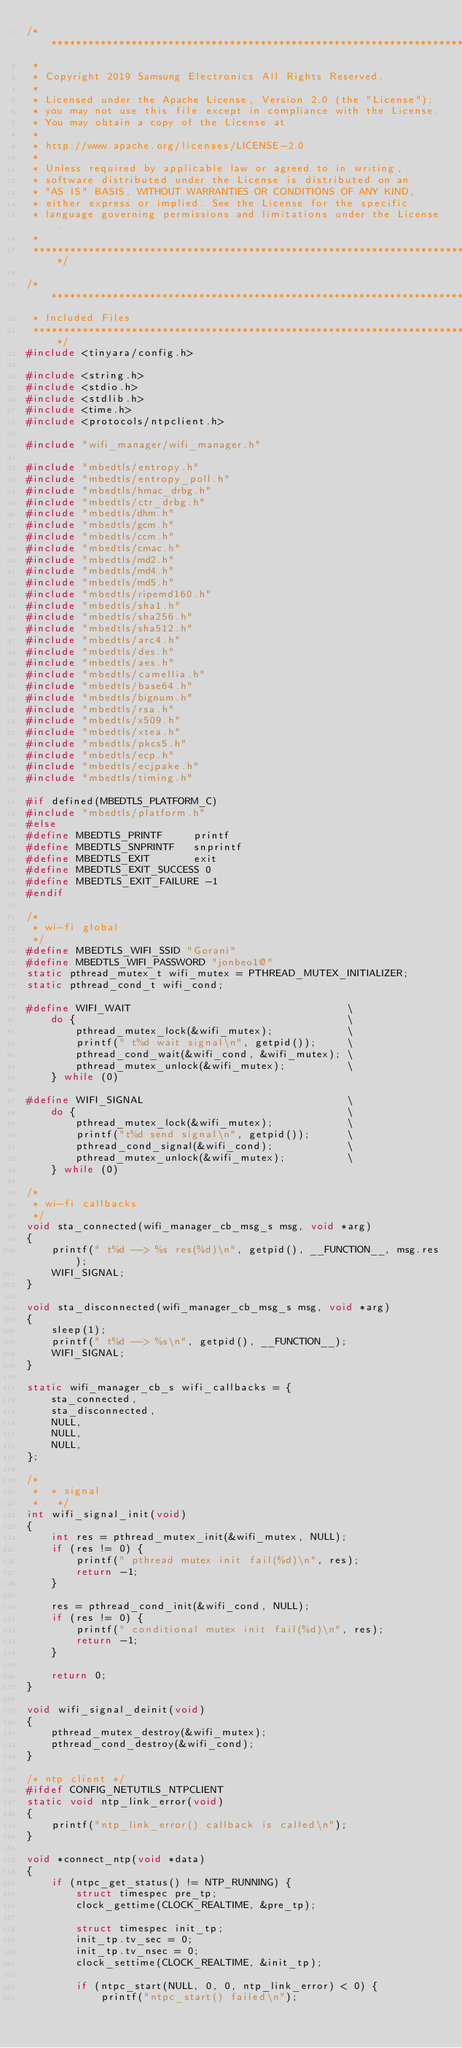<code> <loc_0><loc_0><loc_500><loc_500><_C_>/****************************************************************************
 *
 * Copyright 2019 Samsung Electronics All Rights Reserved.
 *
 * Licensed under the Apache License, Version 2.0 (the "License");
 * you may not use this file except in compliance with the License.
 * You may obtain a copy of the License at
 *
 * http://www.apache.org/licenses/LICENSE-2.0
 *
 * Unless required by applicable law or agreed to in writing,
 * software distributed under the License is distributed on an
 * "AS IS" BASIS, WITHOUT WARRANTIES OR CONDITIONS OF ANY KIND,
 * either express or implied. See the License for the specific
 * language governing permissions and limitations under the License.
 *
 ****************************************************************************/

/****************************************************************************
 * Included Files
 ****************************************************************************/
#include <tinyara/config.h>

#include <string.h>
#include <stdio.h>
#include <stdlib.h>
#include <time.h>
#include <protocols/ntpclient.h>

#include "wifi_manager/wifi_manager.h"

#include "mbedtls/entropy.h"
#include "mbedtls/entropy_poll.h"
#include "mbedtls/hmac_drbg.h"
#include "mbedtls/ctr_drbg.h"
#include "mbedtls/dhm.h"
#include "mbedtls/gcm.h"
#include "mbedtls/ccm.h"
#include "mbedtls/cmac.h"
#include "mbedtls/md2.h"
#include "mbedtls/md4.h"
#include "mbedtls/md5.h"
#include "mbedtls/ripemd160.h"
#include "mbedtls/sha1.h"
#include "mbedtls/sha256.h"
#include "mbedtls/sha512.h"
#include "mbedtls/arc4.h"
#include "mbedtls/des.h"
#include "mbedtls/aes.h"
#include "mbedtls/camellia.h"
#include "mbedtls/base64.h"
#include "mbedtls/bignum.h"
#include "mbedtls/rsa.h"
#include "mbedtls/x509.h"
#include "mbedtls/xtea.h"
#include "mbedtls/pkcs5.h"
#include "mbedtls/ecp.h"
#include "mbedtls/ecjpake.h"
#include "mbedtls/timing.h"

#if defined(MBEDTLS_PLATFORM_C)
#include "mbedtls/platform.h"
#else
#define MBEDTLS_PRINTF     printf
#define MBEDTLS_SNPRINTF   snprintf
#define MBEDTLS_EXIT       exit
#define MBEDTLS_EXIT_SUCCESS 0
#define MBEDTLS_EXIT_FAILURE -1
#endif

/*
 * wi-fi global
 */
#define MBEDTLS_WIFI_SSID "Gorani"
#define MBEDTLS_WIFI_PASSWORD "jonbeo1@"
static pthread_mutex_t wifi_mutex = PTHREAD_MUTEX_INITIALIZER;
static pthread_cond_t wifi_cond;

#define WIFI_WAIT                                   \
	do {                                            \
		pthread_mutex_lock(&wifi_mutex);            \
		printf(" t%d wait signal\n", getpid());     \
		pthread_cond_wait(&wifi_cond, &wifi_mutex); \
		pthread_mutex_unlock(&wifi_mutex);          \
	} while (0)

#define WIFI_SIGNAL                                 \
	do {                                            \
		pthread_mutex_lock(&wifi_mutex);            \
		printf("t%d send signal\n", getpid());      \
		pthread_cond_signal(&wifi_cond);            \
		pthread_mutex_unlock(&wifi_mutex);          \
	} while (0)

/*
 * wi-fi callbacks
 */
void sta_connected(wifi_manager_cb_msg_s msg, void *arg)
{
	printf(" t%d --> %s res(%d)\n", getpid(), __FUNCTION__, msg.res);
	WIFI_SIGNAL;
}

void sta_disconnected(wifi_manager_cb_msg_s msg, void *arg)
{
	sleep(1);
	printf(" t%d --> %s\n", getpid(), __FUNCTION__);
	WIFI_SIGNAL;
}

static wifi_manager_cb_s wifi_callbacks = {
	sta_connected,
	sta_disconnected,
	NULL,
	NULL,
	NULL,
};

/*
 *  * signal
 *   */
int wifi_signal_init(void)
{
	int res = pthread_mutex_init(&wifi_mutex, NULL);
	if (res != 0) {
		printf(" pthread mutex init fail(%d)\n", res);
		return -1;
	}

	res = pthread_cond_init(&wifi_cond, NULL);
	if (res != 0) {
		printf(" conditional mutex init fail(%d)\n", res);
		return -1;
	}

	return 0;
}

void wifi_signal_deinit(void)
{
	pthread_mutex_destroy(&wifi_mutex);
	pthread_cond_destroy(&wifi_cond);
}

/* ntp client */
#ifdef CONFIG_NETUTILS_NTPCLIENT
static void ntp_link_error(void)
{
	printf("ntp_link_error() callback is called\n");
}

void *connect_ntp(void *data)
{
	if (ntpc_get_status() != NTP_RUNNING) {
		struct timespec pre_tp;
		clock_gettime(CLOCK_REALTIME, &pre_tp);

		struct timespec init_tp;
		init_tp.tv_sec = 0;
		init_tp.tv_nsec = 0;
		clock_settime(CLOCK_REALTIME, &init_tp);

		if (ntpc_start(NULL, 0, 0, ntp_link_error) < 0) {
			printf("ntpc_start() failed\n");</code> 